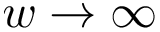<formula> <loc_0><loc_0><loc_500><loc_500>w \to \infty</formula> 